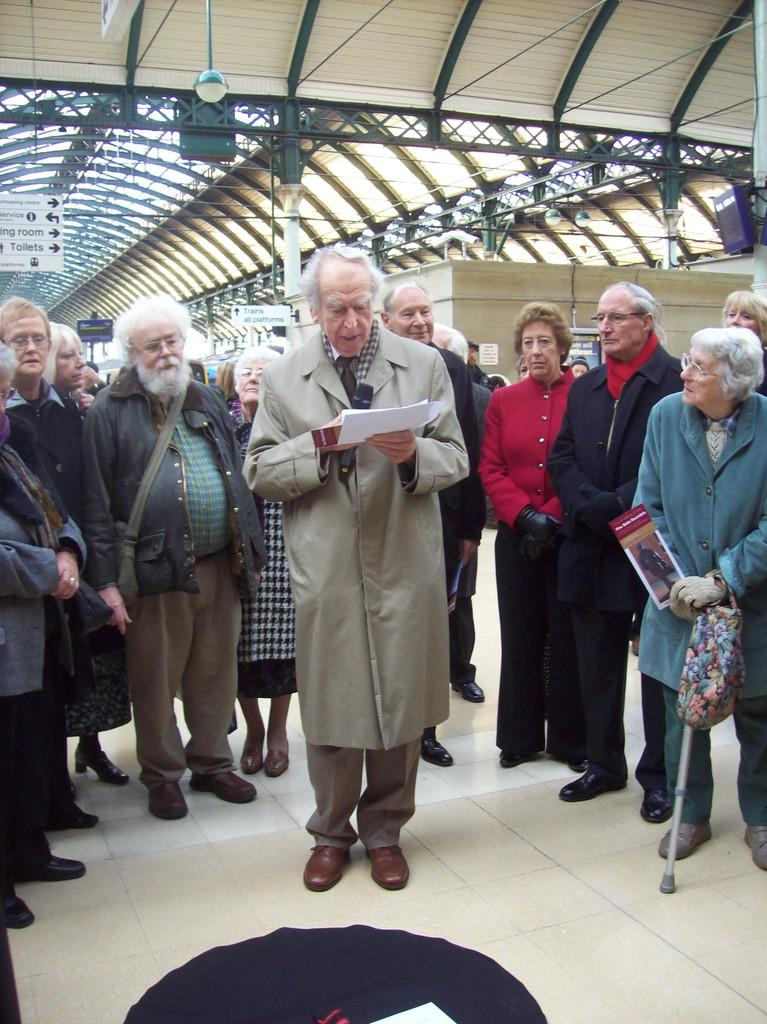What is happening with the persons in the image? The persons are standing on the floor. Can you describe the person in the middle? There is a person holding a paper standing in the middle. What is visible at the top of the image? The roof is visible at the top of the image. What type of cabbage can be seen hanging from the lamp in the image? There is no cabbage or lamp present in the image. 